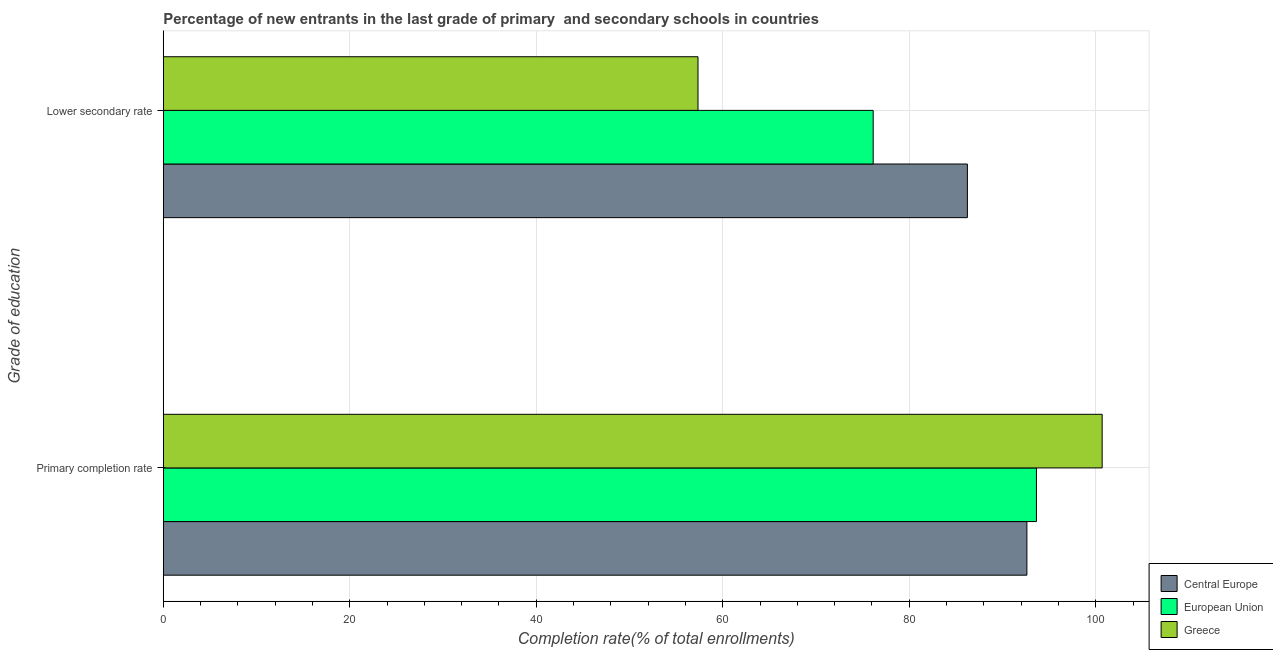How many different coloured bars are there?
Keep it short and to the point. 3. How many bars are there on the 2nd tick from the top?
Make the answer very short. 3. What is the label of the 2nd group of bars from the top?
Your answer should be very brief. Primary completion rate. What is the completion rate in primary schools in Central Europe?
Give a very brief answer. 92.62. Across all countries, what is the maximum completion rate in secondary schools?
Give a very brief answer. 86.23. Across all countries, what is the minimum completion rate in primary schools?
Provide a short and direct response. 92.62. In which country was the completion rate in secondary schools maximum?
Your answer should be very brief. Central Europe. In which country was the completion rate in primary schools minimum?
Provide a succinct answer. Central Europe. What is the total completion rate in secondary schools in the graph?
Ensure brevity in your answer.  219.71. What is the difference between the completion rate in secondary schools in Greece and that in Central Europe?
Your answer should be compact. -28.89. What is the difference between the completion rate in secondary schools in Greece and the completion rate in primary schools in Central Europe?
Your response must be concise. -35.27. What is the average completion rate in primary schools per country?
Offer a very short reply. 95.65. What is the difference between the completion rate in secondary schools and completion rate in primary schools in Central Europe?
Make the answer very short. -6.38. In how many countries, is the completion rate in primary schools greater than 64 %?
Ensure brevity in your answer.  3. What is the ratio of the completion rate in primary schools in European Union to that in Greece?
Make the answer very short. 0.93. Is the completion rate in primary schools in Central Europe less than that in European Union?
Offer a terse response. Yes. In how many countries, is the completion rate in secondary schools greater than the average completion rate in secondary schools taken over all countries?
Give a very brief answer. 2. What does the 2nd bar from the top in Lower secondary rate represents?
Give a very brief answer. European Union. What does the 2nd bar from the bottom in Primary completion rate represents?
Make the answer very short. European Union. How many bars are there?
Make the answer very short. 6. How many countries are there in the graph?
Provide a short and direct response. 3. What is the difference between two consecutive major ticks on the X-axis?
Your answer should be very brief. 20. Are the values on the major ticks of X-axis written in scientific E-notation?
Offer a very short reply. No. Does the graph contain any zero values?
Ensure brevity in your answer.  No. How many legend labels are there?
Provide a short and direct response. 3. What is the title of the graph?
Make the answer very short. Percentage of new entrants in the last grade of primary  and secondary schools in countries. What is the label or title of the X-axis?
Offer a terse response. Completion rate(% of total enrollments). What is the label or title of the Y-axis?
Your answer should be very brief. Grade of education. What is the Completion rate(% of total enrollments) in Central Europe in Primary completion rate?
Provide a short and direct response. 92.62. What is the Completion rate(% of total enrollments) of European Union in Primary completion rate?
Give a very brief answer. 93.64. What is the Completion rate(% of total enrollments) in Greece in Primary completion rate?
Ensure brevity in your answer.  100.69. What is the Completion rate(% of total enrollments) of Central Europe in Lower secondary rate?
Your response must be concise. 86.23. What is the Completion rate(% of total enrollments) of European Union in Lower secondary rate?
Provide a succinct answer. 76.13. What is the Completion rate(% of total enrollments) of Greece in Lower secondary rate?
Your response must be concise. 57.35. Across all Grade of education, what is the maximum Completion rate(% of total enrollments) in Central Europe?
Ensure brevity in your answer.  92.62. Across all Grade of education, what is the maximum Completion rate(% of total enrollments) in European Union?
Ensure brevity in your answer.  93.64. Across all Grade of education, what is the maximum Completion rate(% of total enrollments) of Greece?
Make the answer very short. 100.69. Across all Grade of education, what is the minimum Completion rate(% of total enrollments) of Central Europe?
Give a very brief answer. 86.23. Across all Grade of education, what is the minimum Completion rate(% of total enrollments) of European Union?
Provide a succinct answer. 76.13. Across all Grade of education, what is the minimum Completion rate(% of total enrollments) in Greece?
Your response must be concise. 57.35. What is the total Completion rate(% of total enrollments) in Central Europe in the graph?
Offer a terse response. 178.85. What is the total Completion rate(% of total enrollments) in European Union in the graph?
Your response must be concise. 169.77. What is the total Completion rate(% of total enrollments) in Greece in the graph?
Provide a short and direct response. 158.03. What is the difference between the Completion rate(% of total enrollments) in Central Europe in Primary completion rate and that in Lower secondary rate?
Offer a very short reply. 6.38. What is the difference between the Completion rate(% of total enrollments) of European Union in Primary completion rate and that in Lower secondary rate?
Your answer should be compact. 17.51. What is the difference between the Completion rate(% of total enrollments) in Greece in Primary completion rate and that in Lower secondary rate?
Keep it short and to the point. 43.34. What is the difference between the Completion rate(% of total enrollments) of Central Europe in Primary completion rate and the Completion rate(% of total enrollments) of European Union in Lower secondary rate?
Offer a very short reply. 16.48. What is the difference between the Completion rate(% of total enrollments) of Central Europe in Primary completion rate and the Completion rate(% of total enrollments) of Greece in Lower secondary rate?
Your answer should be compact. 35.27. What is the difference between the Completion rate(% of total enrollments) in European Union in Primary completion rate and the Completion rate(% of total enrollments) in Greece in Lower secondary rate?
Provide a succinct answer. 36.29. What is the average Completion rate(% of total enrollments) of Central Europe per Grade of education?
Keep it short and to the point. 89.43. What is the average Completion rate(% of total enrollments) in European Union per Grade of education?
Ensure brevity in your answer.  84.89. What is the average Completion rate(% of total enrollments) in Greece per Grade of education?
Offer a very short reply. 79.02. What is the difference between the Completion rate(% of total enrollments) of Central Europe and Completion rate(% of total enrollments) of European Union in Primary completion rate?
Your answer should be compact. -1.02. What is the difference between the Completion rate(% of total enrollments) of Central Europe and Completion rate(% of total enrollments) of Greece in Primary completion rate?
Offer a terse response. -8.07. What is the difference between the Completion rate(% of total enrollments) of European Union and Completion rate(% of total enrollments) of Greece in Primary completion rate?
Give a very brief answer. -7.05. What is the difference between the Completion rate(% of total enrollments) of Central Europe and Completion rate(% of total enrollments) of European Union in Lower secondary rate?
Offer a very short reply. 10.1. What is the difference between the Completion rate(% of total enrollments) in Central Europe and Completion rate(% of total enrollments) in Greece in Lower secondary rate?
Offer a terse response. 28.89. What is the difference between the Completion rate(% of total enrollments) of European Union and Completion rate(% of total enrollments) of Greece in Lower secondary rate?
Make the answer very short. 18.79. What is the ratio of the Completion rate(% of total enrollments) of Central Europe in Primary completion rate to that in Lower secondary rate?
Give a very brief answer. 1.07. What is the ratio of the Completion rate(% of total enrollments) of European Union in Primary completion rate to that in Lower secondary rate?
Your answer should be very brief. 1.23. What is the ratio of the Completion rate(% of total enrollments) in Greece in Primary completion rate to that in Lower secondary rate?
Your response must be concise. 1.76. What is the difference between the highest and the second highest Completion rate(% of total enrollments) in Central Europe?
Your answer should be compact. 6.38. What is the difference between the highest and the second highest Completion rate(% of total enrollments) in European Union?
Your answer should be very brief. 17.51. What is the difference between the highest and the second highest Completion rate(% of total enrollments) of Greece?
Your answer should be compact. 43.34. What is the difference between the highest and the lowest Completion rate(% of total enrollments) of Central Europe?
Provide a succinct answer. 6.38. What is the difference between the highest and the lowest Completion rate(% of total enrollments) in European Union?
Offer a terse response. 17.51. What is the difference between the highest and the lowest Completion rate(% of total enrollments) in Greece?
Keep it short and to the point. 43.34. 